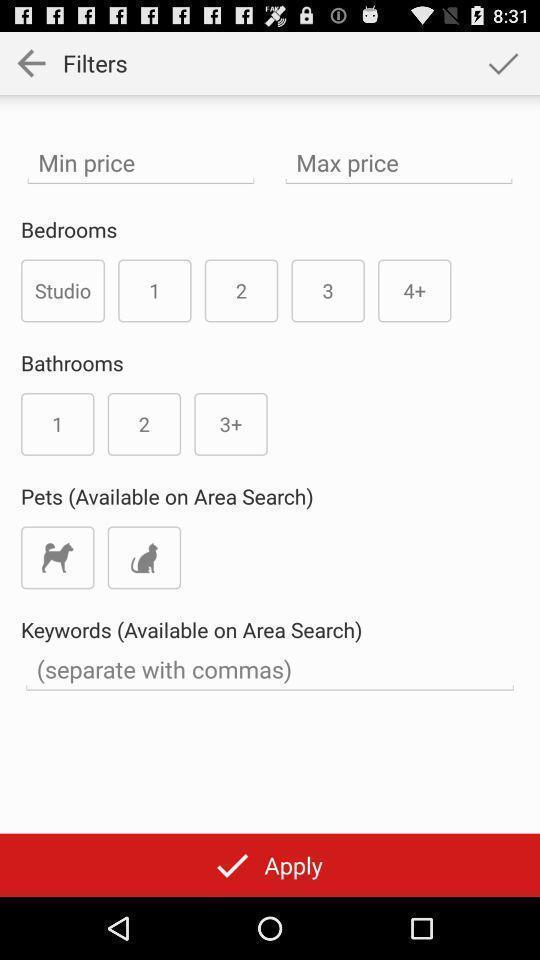Provide a description of this screenshot. Screen page to find apartments. 